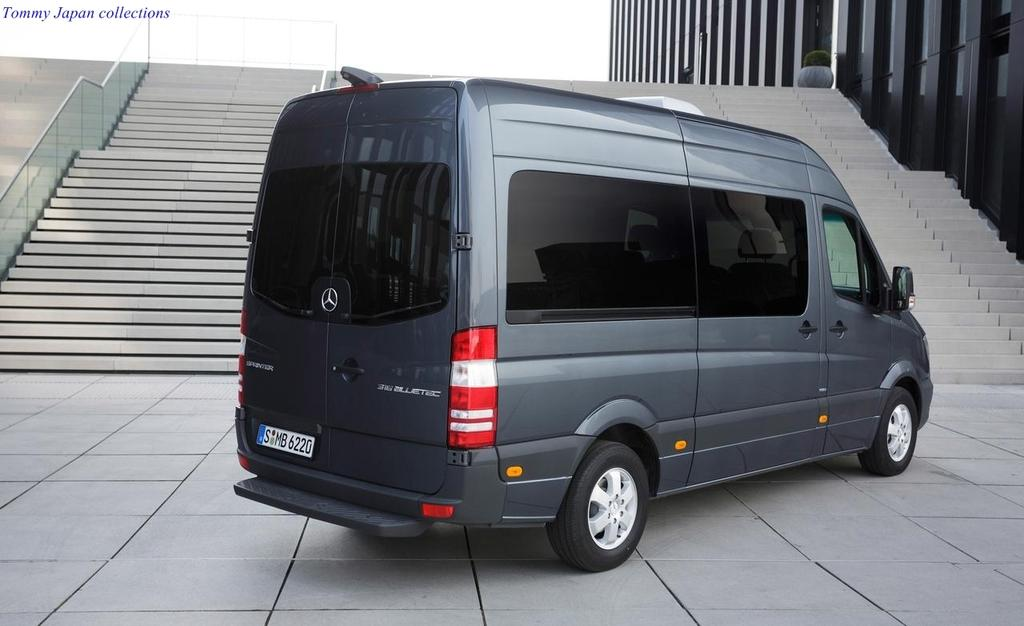<image>
Render a clear and concise summary of the photo. A cobalt-colored transport van with dark glass was built by the Mercedes-Benz company. 